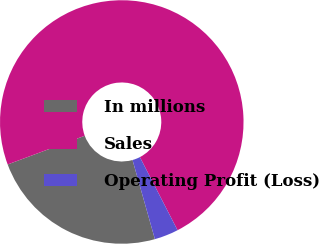Convert chart. <chart><loc_0><loc_0><loc_500><loc_500><pie_chart><fcel>In millions<fcel>Sales<fcel>Operating Profit (Loss)<nl><fcel>23.71%<fcel>73.09%<fcel>3.19%<nl></chart> 